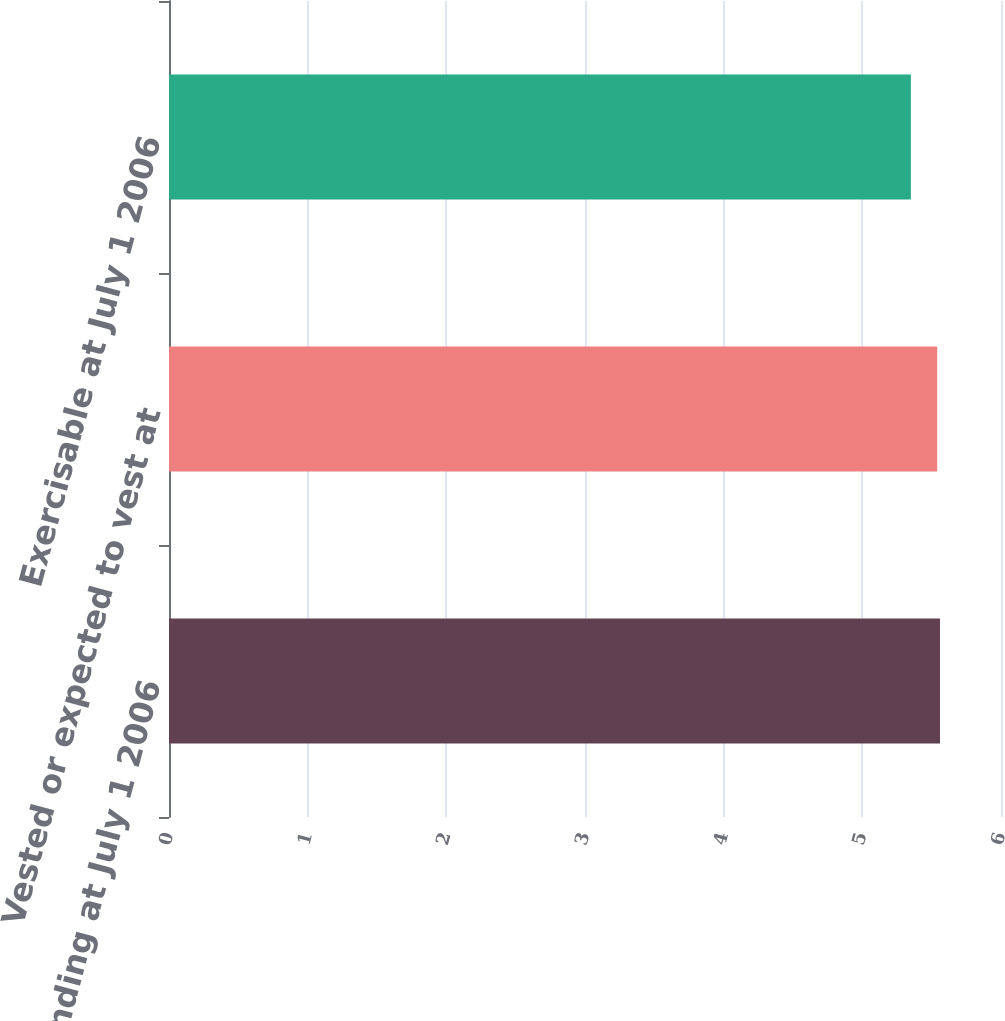<chart> <loc_0><loc_0><loc_500><loc_500><bar_chart><fcel>Outstanding at July 1 2006<fcel>Vested or expected to vest at<fcel>Exercisable at July 1 2006<nl><fcel>5.56<fcel>5.54<fcel>5.35<nl></chart> 